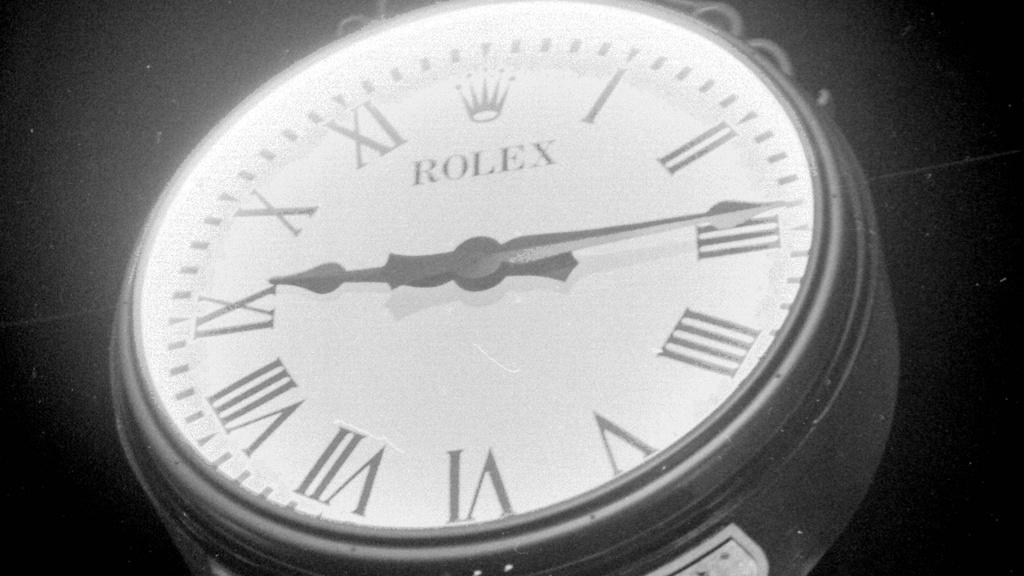<image>
Relay a brief, clear account of the picture shown. A circular Rolex clock depicting the time as 9:15 in Roman numerals. 